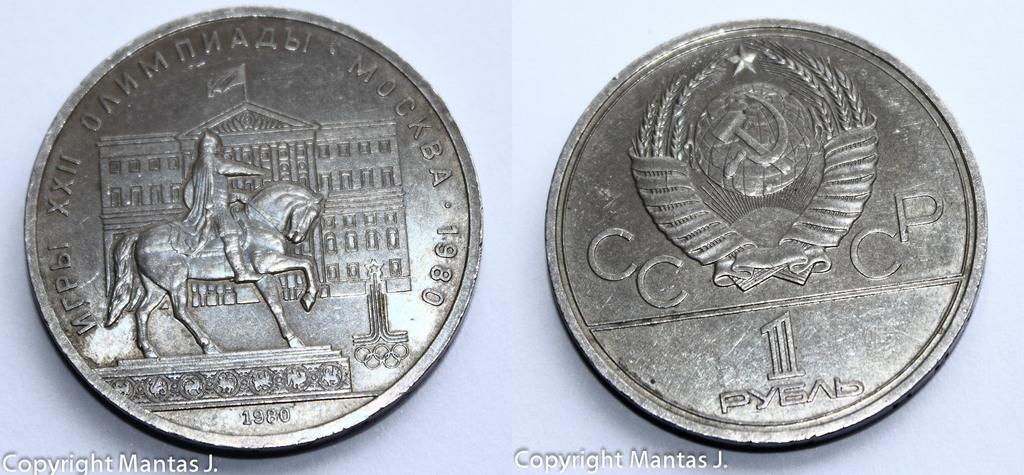<image>
Write a terse but informative summary of the picture. Two silver coins shown the left one was made in 1980. 